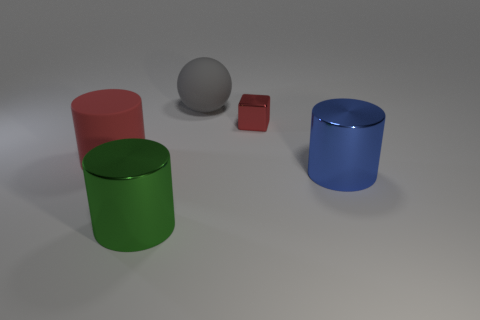Does it look like the lighting in the scene is coming from a specific direction? Yes, based on the shadows and highlights on the objects, the light source seems to be coming from the upper left side of the image. This is indicated by the shadows being cast to the lower right side of each object. 